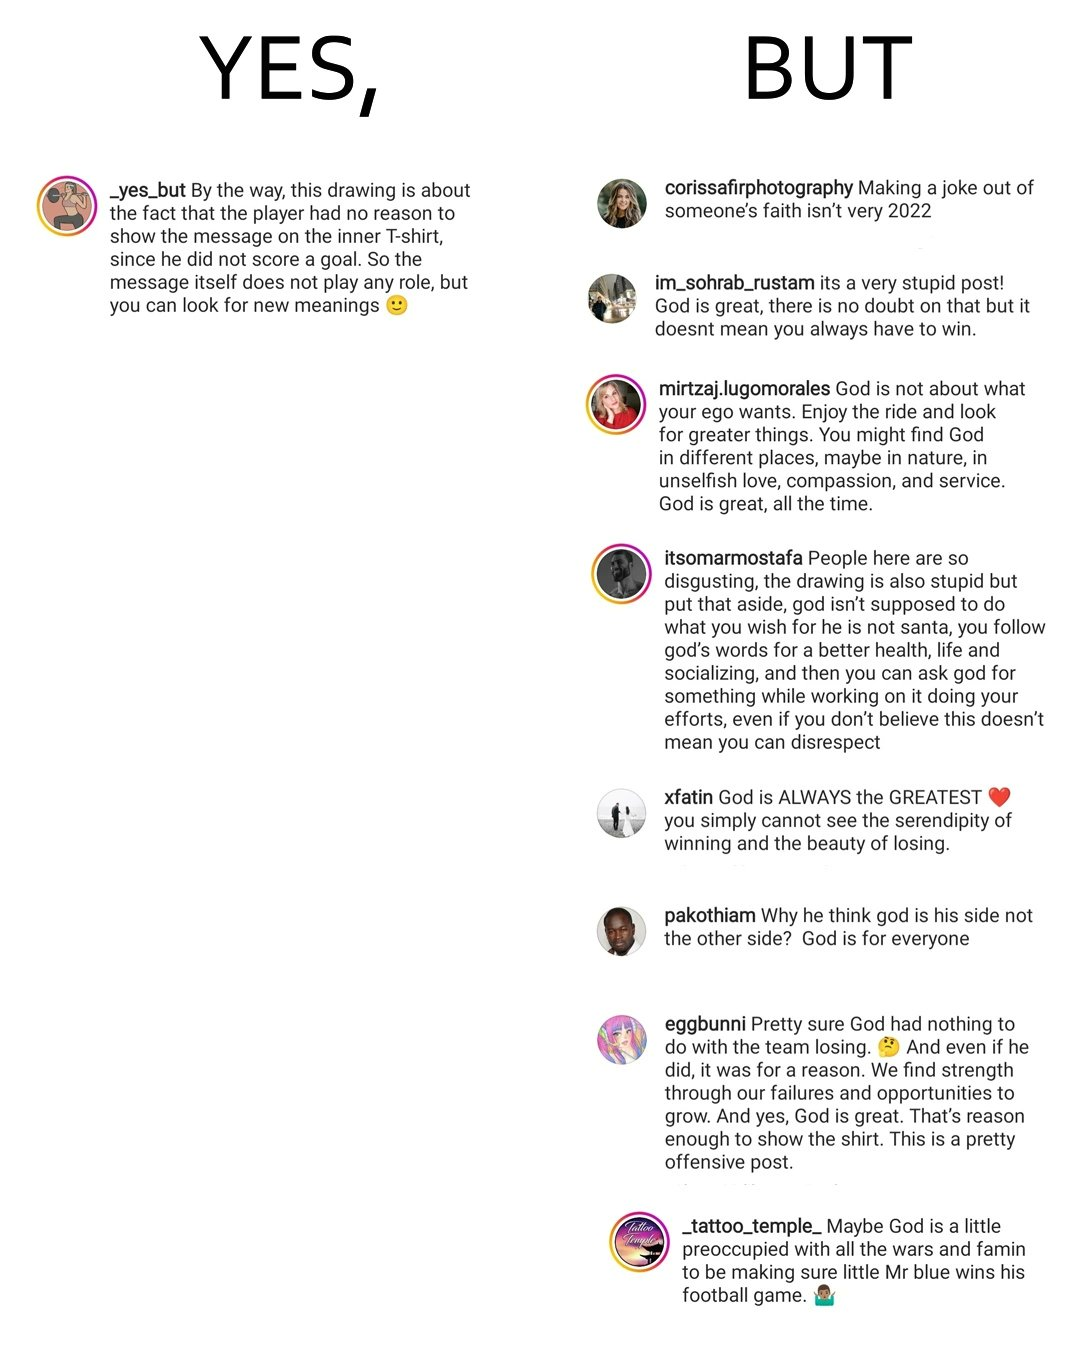Compare the left and right sides of this image. In the left part of the image: a comment on some post made on any social media, probably some clarification or description of some post In the right part of the image: some comments on some post over some social media platform about criticising some meme materials, or videos 